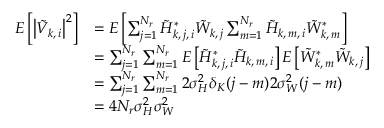Convert formula to latex. <formula><loc_0><loc_0><loc_500><loc_500>\begin{array} { r l } { E \left [ \left | \tilde { V } _ { k , \, i } \right | ^ { 2 } \right ] } & { = E \left [ \sum _ { j = 1 } ^ { N _ { r } } \tilde { H } _ { k , \, j , \, i } ^ { * } \tilde { W } _ { k , \, j } \sum _ { m = 1 } ^ { N _ { r } } \tilde { H } _ { k , \, m , \, i } \tilde { W } _ { k , \, m } ^ { * } \right ] } \\ & { = \sum _ { j = 1 } ^ { N _ { r } } \sum _ { m = 1 } ^ { N _ { r } } E \left [ \tilde { H } _ { k , \, j , \, i } ^ { * } \tilde { H } _ { k , \, m , \, i } \right ] E \left [ \tilde { W } _ { k , \, m } ^ { * } \tilde { W } _ { k , \, j } \right ] } \\ & { = \sum _ { j = 1 } ^ { N _ { r } } \sum _ { m = 1 } ^ { N _ { r } } 2 \sigma _ { H } ^ { 2 } \delta _ { K } ( j - m ) 2 \sigma _ { W } ^ { 2 } ( j - m ) } \\ & { = 4 N _ { r } \sigma _ { H } ^ { 2 } \sigma _ { W } ^ { 2 } } \end{array}</formula> 